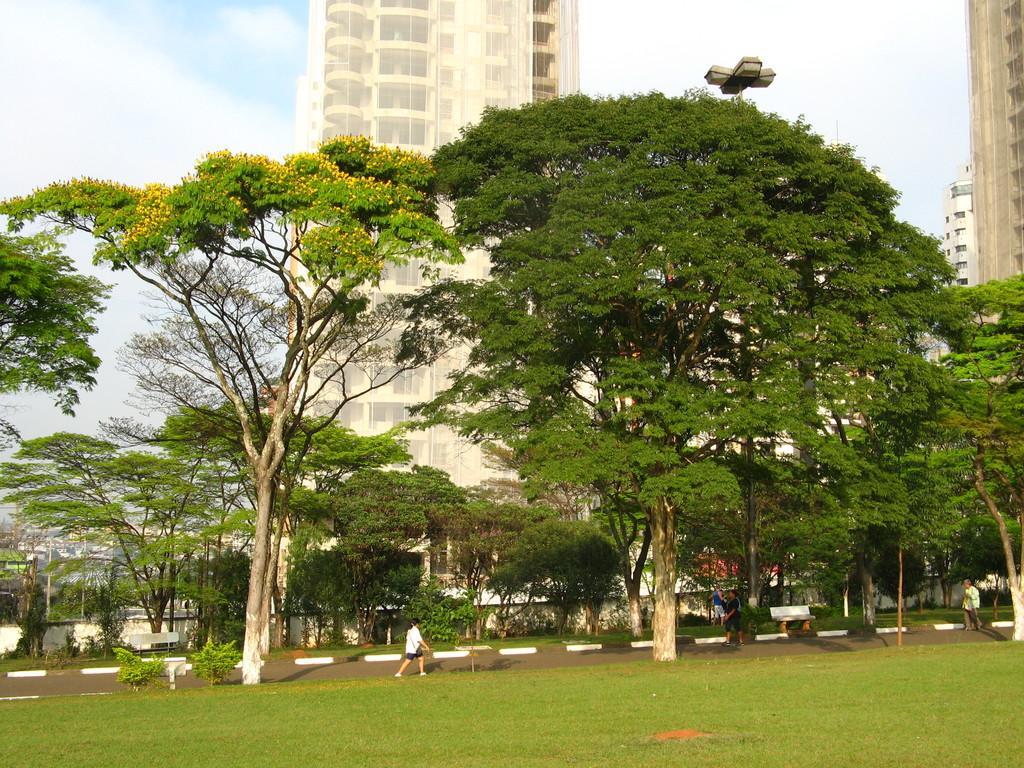How would you summarize this image in a sentence or two? In this image in the center there is grass on the ground and there is a kid walking. In the background there are trees and there are buildings, there is a pole and the sky is cloudy. 